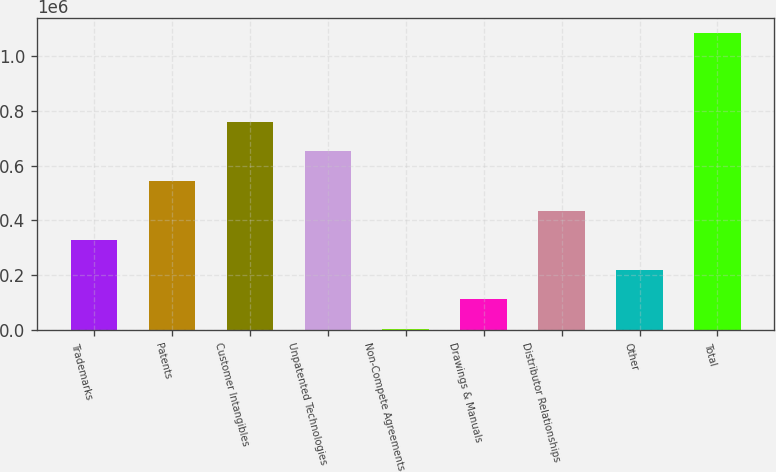<chart> <loc_0><loc_0><loc_500><loc_500><bar_chart><fcel>Trademarks<fcel>Patents<fcel>Customer Intangibles<fcel>Unpatented Technologies<fcel>Non-Compete Agreements<fcel>Drawings & Manuals<fcel>Distributor Relationships<fcel>Other<fcel>Total<nl><fcel>327831<fcel>544068<fcel>760305<fcel>652187<fcel>3475<fcel>111594<fcel>435949<fcel>219712<fcel>1.08466e+06<nl></chart> 